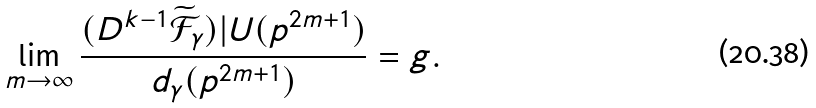<formula> <loc_0><loc_0><loc_500><loc_500>\lim _ { m \rightarrow \infty } \frac { ( D ^ { k - 1 } \widetilde { \mathcal { F } } _ { \gamma } ) | U ( p ^ { 2 m + 1 } ) } { d _ { \gamma } ( p ^ { 2 m + 1 } ) } = g .</formula> 